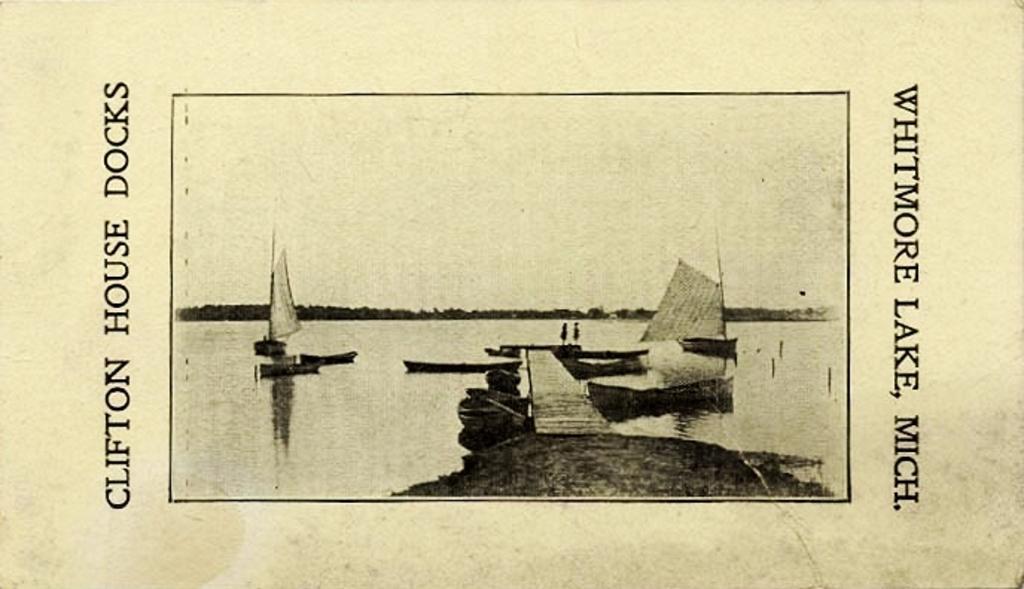Describe this image in one or two sentences. This is a black and white image. In the middle of the image we can see a picture and text on the top and bottom. In the picture we can see trees, river, boats, rocks and a walkway bridge. 